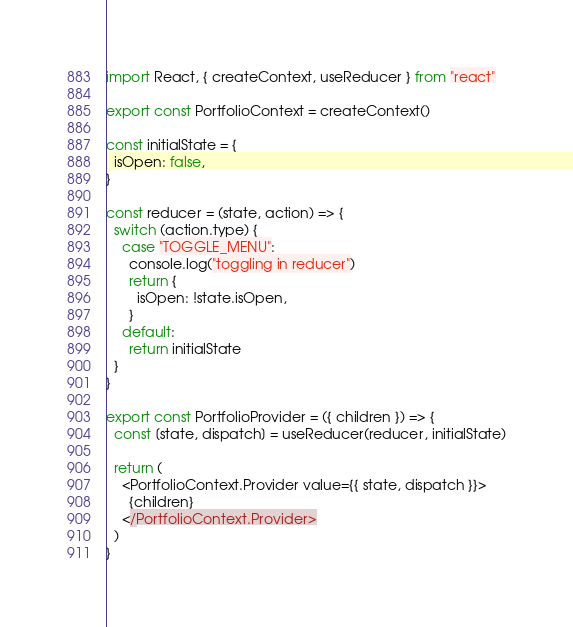Convert code to text. <code><loc_0><loc_0><loc_500><loc_500><_JavaScript_>import React, { createContext, useReducer } from "react"

export const PortfolioContext = createContext()

const initialState = {
  isOpen: false,
}

const reducer = (state, action) => {
  switch (action.type) {
    case "TOGGLE_MENU":
      console.log("toggling in reducer")
      return {
        isOpen: !state.isOpen,
      }
    default:
      return initialState
  }
}

export const PortfolioProvider = ({ children }) => {
  const [state, dispatch] = useReducer(reducer, initialState)

  return (
    <PortfolioContext.Provider value={{ state, dispatch }}>
      {children}
    </PortfolioContext.Provider>
  )
}
</code> 